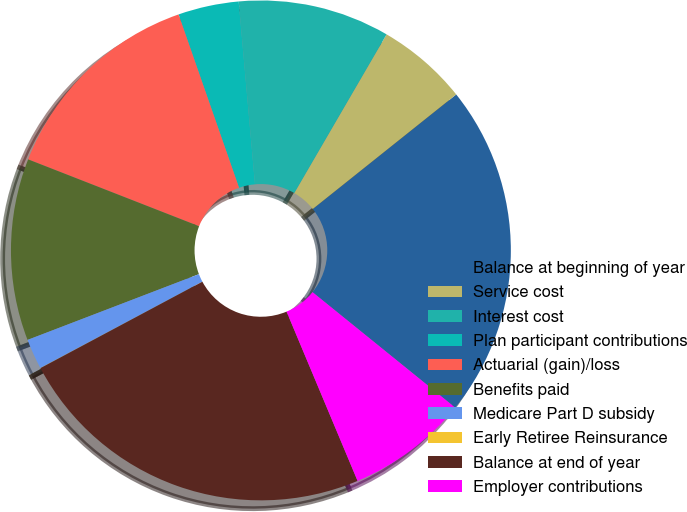<chart> <loc_0><loc_0><loc_500><loc_500><pie_chart><fcel>Balance at beginning of year<fcel>Service cost<fcel>Interest cost<fcel>Plan participant contributions<fcel>Actuarial (gain)/loss<fcel>Benefits paid<fcel>Medicare Part D subsidy<fcel>Early Retiree Reinsurance<fcel>Balance at end of year<fcel>Employer contributions<nl><fcel>21.55%<fcel>5.89%<fcel>9.8%<fcel>3.93%<fcel>13.72%<fcel>11.76%<fcel>1.97%<fcel>0.01%<fcel>23.51%<fcel>7.85%<nl></chart> 